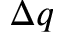Convert formula to latex. <formula><loc_0><loc_0><loc_500><loc_500>\Delta q</formula> 